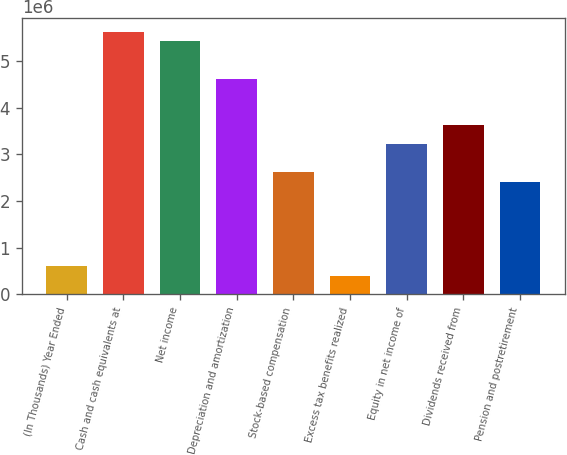Convert chart. <chart><loc_0><loc_0><loc_500><loc_500><bar_chart><fcel>(In Thousands) Year Ended<fcel>Cash and cash equivalents at<fcel>Net income<fcel>Depreciation and amortization<fcel>Stock-based compensation<fcel>Excess tax benefits realized<fcel>Equity in net income of<fcel>Dividends received from<fcel>Pension and postretirement<nl><fcel>604213<fcel>5.63391e+06<fcel>5.43272e+06<fcel>4.62797e+06<fcel>2.61609e+06<fcel>403025<fcel>3.21966e+06<fcel>3.62203e+06<fcel>2.4149e+06<nl></chart> 